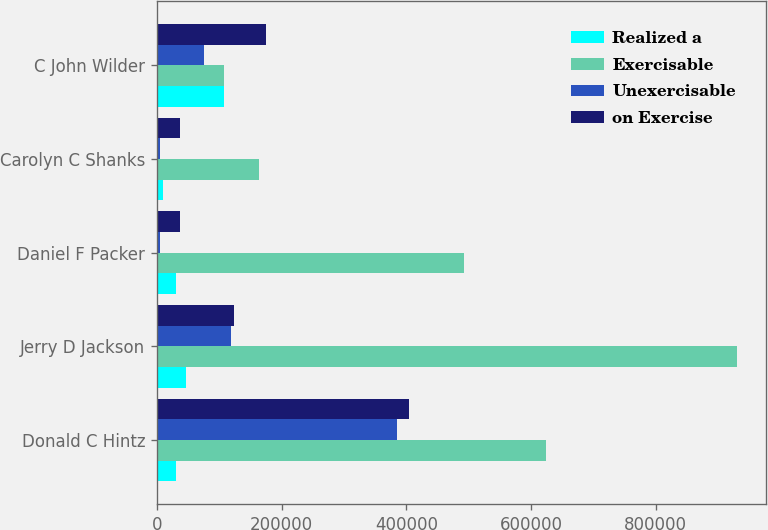<chart> <loc_0><loc_0><loc_500><loc_500><stacked_bar_chart><ecel><fcel>Donald C Hintz<fcel>Jerry D Jackson<fcel>Daniel F Packer<fcel>Carolyn C Shanks<fcel>C John Wilder<nl><fcel>Realized a<fcel>30000<fcel>45927<fcel>30083<fcel>10351<fcel>108041<nl><fcel>Exercisable<fcel>624375<fcel>930553<fcel>492005<fcel>163659<fcel>108041<nl><fcel>Unexercisable<fcel>384499<fcel>118304<fcel>4933<fcel>4933<fcel>75824<nl><fcel>on Exercise<fcel>405001<fcel>122834<fcel>36534<fcel>36534<fcel>175401<nl></chart> 